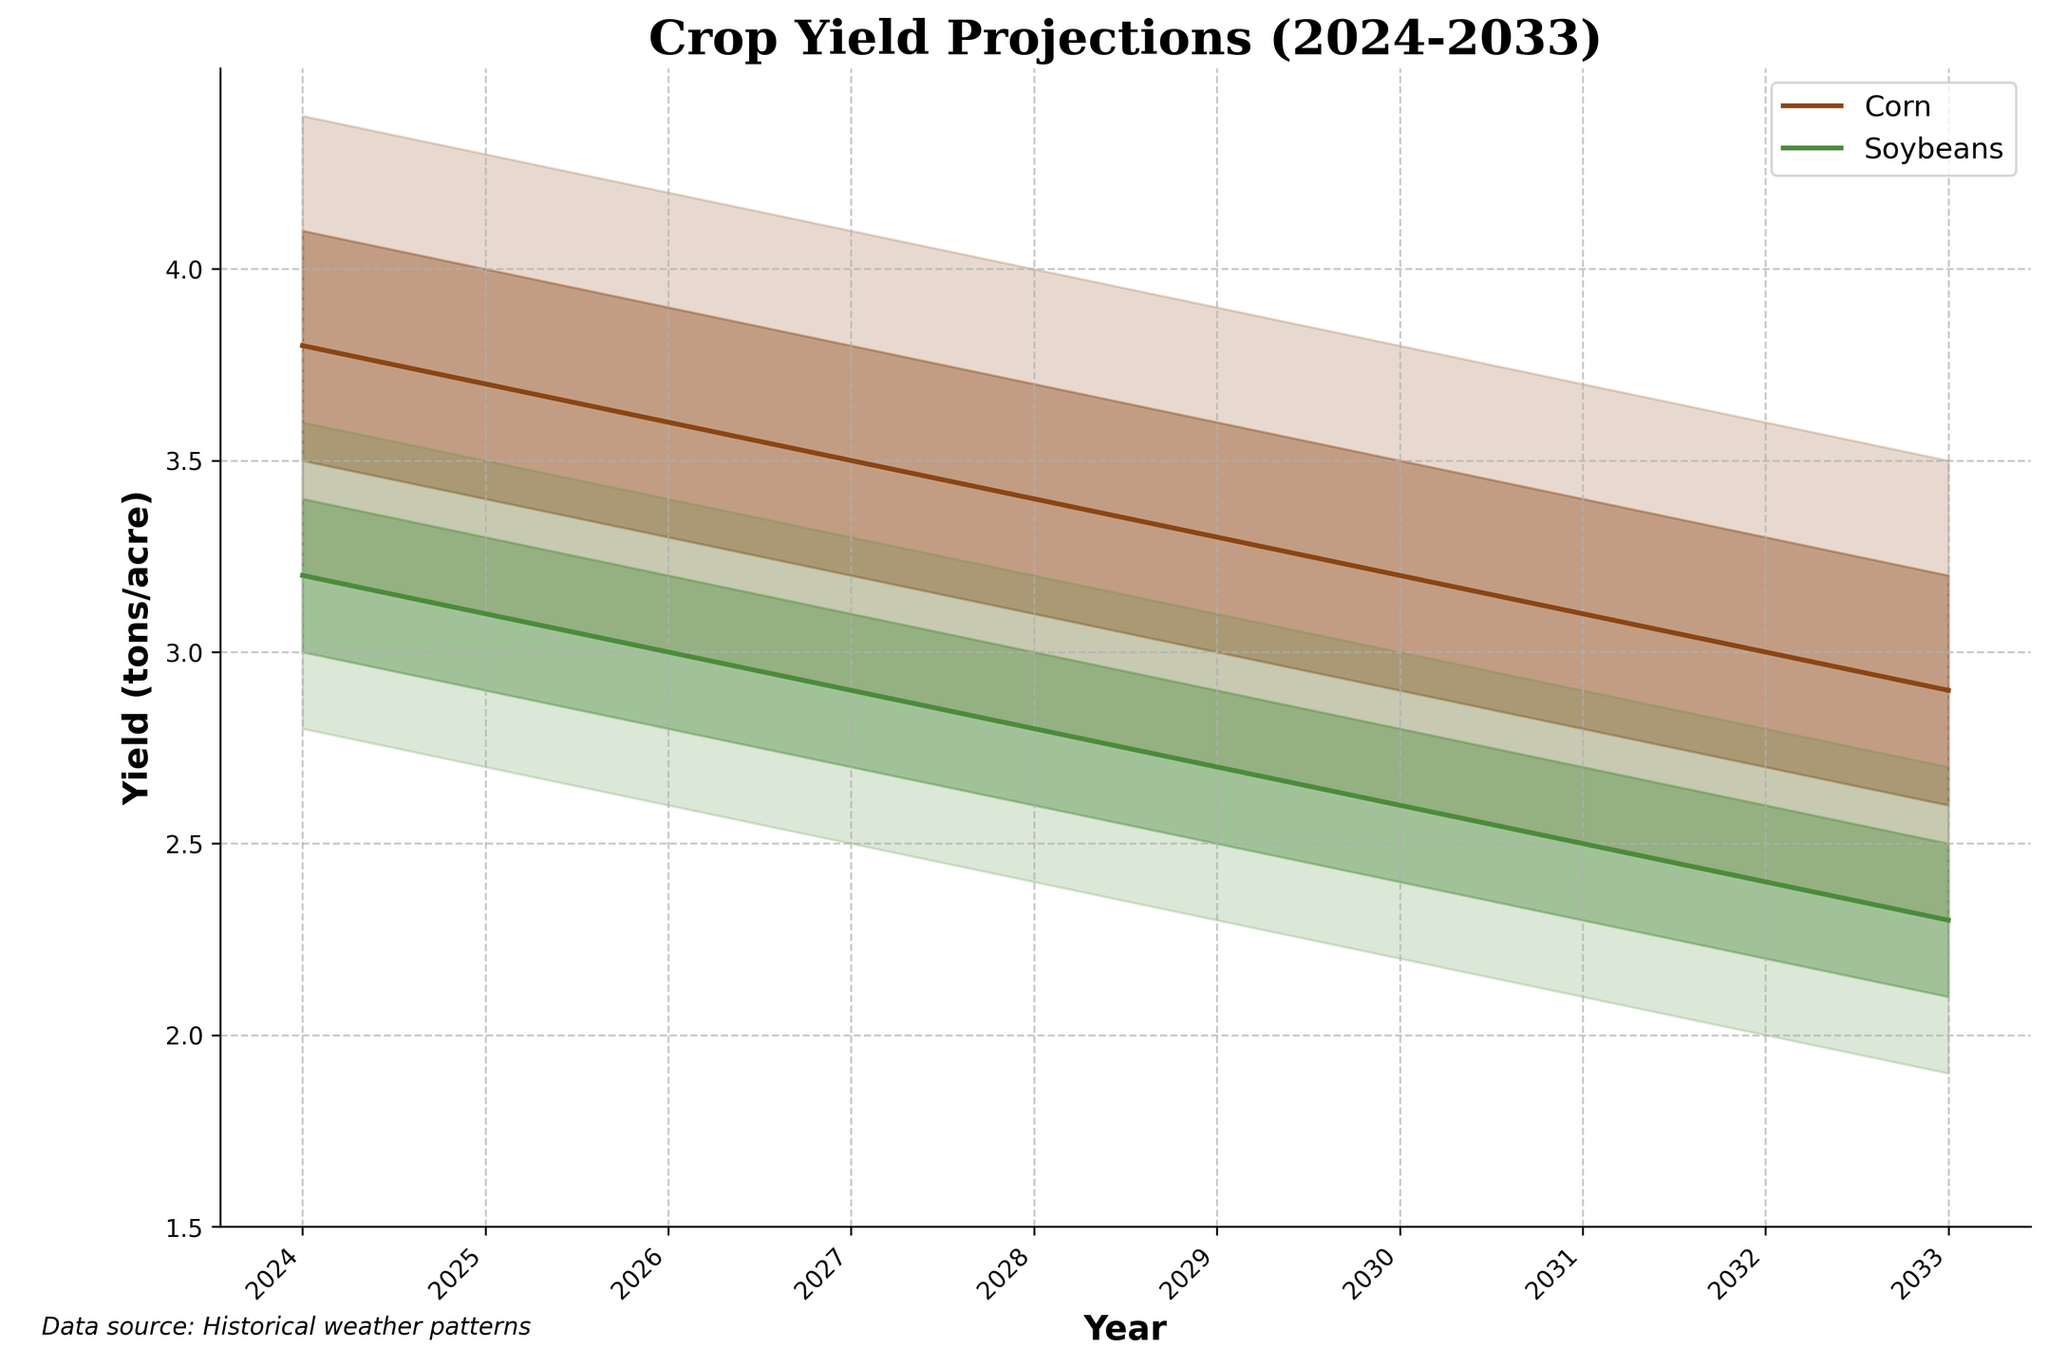Who are the crops projected in the figure? The legend of the figure specifies the two crops that have been projected: Corn and Soybeans.
Answer: Corn and Soybeans What is the general trend of the crop yields for Corn from 2024 to 2033? Upon observing the central line (thickest line) for Corn, it shows a gradual decline from 2024 to 2033. The same trend is observed in the upper and lower bounds.
Answer: A gradual decline Between which years does Soybeans have the smallest projected yield range (difference between the upper bound and lower bound)? By examining the width of the fan chart for Soybeans, it is narrowest from 2024 to 2025.
Answer: 2024 to 2025 What is the projected yield range for Corn in 2024? The fan chart indicates the range of Corn’s yield in 2024 as between the lowest bound (3.2 tons/acre) and the highest bound (4.4 tons/acre).
Answer: 3.2 to 4.4 tons/acre Comparing the median yield values of both crops, which crop has a higher median yield in 2028? The median yield value for Corn in 2028 is 3.4 tons/acre, while the median yield value for Soybeans is 2.8 tons/acre. Thus, Corn has a higher median yield.
Answer: Corn Which year has the lowest projected median yield for Soybeans? By examining the fan chart, the lowest projected median yield for Soybeans is in 2033, which is 2.3 tons/acre.
Answer: 2033 By how much does the median yield for Corn decline from 2024 to 2033? The median yield for Corn in 2024 is 3.8 tons/acre, and in 2033 it is 2.9 tons/acre. The decline is 3.8 - 2.9 = 0.9 tons/acre.
Answer: 0.9 tons/acre What can be inferred about the variability of yield projections between Corn and Soybeans? Observing the width of the fan charts, Corn's yield projections show a wider range of variability compared to Soybeans, indicating more uncertainty in Corn’s yield projections.
Answer: Corn is more variable than Soybeans How are the historical weather patterns relevant to the figure? According to the annotation on the bottom of the figure, the crop yield projections are based on historical weather patterns, which suggest that changes in these patterns influence future crop yields.
Answer: Based on historical weather patterns 